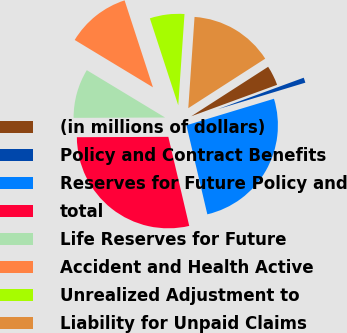Convert chart to OTSL. <chart><loc_0><loc_0><loc_500><loc_500><pie_chart><fcel>(in millions of dollars)<fcel>Policy and Contract Benefits<fcel>Reserves for Future Policy and<fcel>total<fcel>Life Reserves for Future<fcel>Accident and Health Active<fcel>Unrealized Adjustment to<fcel>Liability for Unpaid Claims<nl><fcel>3.51%<fcel>0.91%<fcel>26.01%<fcel>28.61%<fcel>8.72%<fcel>11.32%<fcel>6.11%<fcel>14.81%<nl></chart> 